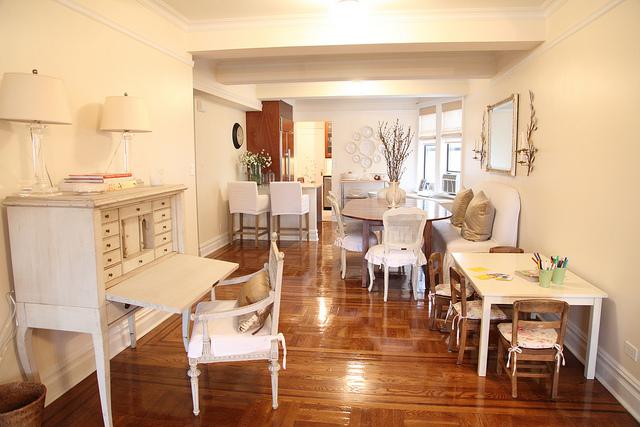Is this floor carpeted?
Answer briefly. No. Are the floors clean?
Answer briefly. Yes. How many chairs are in the room?
Write a very short answer. 8. 